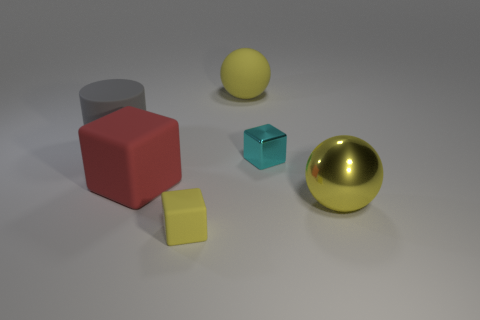How many balls are either large gray rubber things or tiny things?
Offer a very short reply. 0. What is the size of the thing that is to the right of the metallic object that is behind the big matte object in front of the large gray matte object?
Offer a terse response. Large. The thing that is both in front of the large gray cylinder and on the left side of the small matte object is what color?
Your response must be concise. Red. Does the cyan thing have the same size as the yellow rubber thing that is in front of the big red matte object?
Keep it short and to the point. Yes. Is there anything else that has the same shape as the tiny rubber thing?
Your answer should be very brief. Yes. What color is the other small matte thing that is the same shape as the red object?
Offer a very short reply. Yellow. Is the cyan cube the same size as the gray cylinder?
Provide a succinct answer. No. How many other things are the same size as the red rubber cube?
Your answer should be very brief. 3. What number of things are big yellow objects that are behind the big gray matte cylinder or large things that are behind the large gray thing?
Your response must be concise. 1. What shape is the red object that is the same size as the gray matte object?
Offer a very short reply. Cube. 